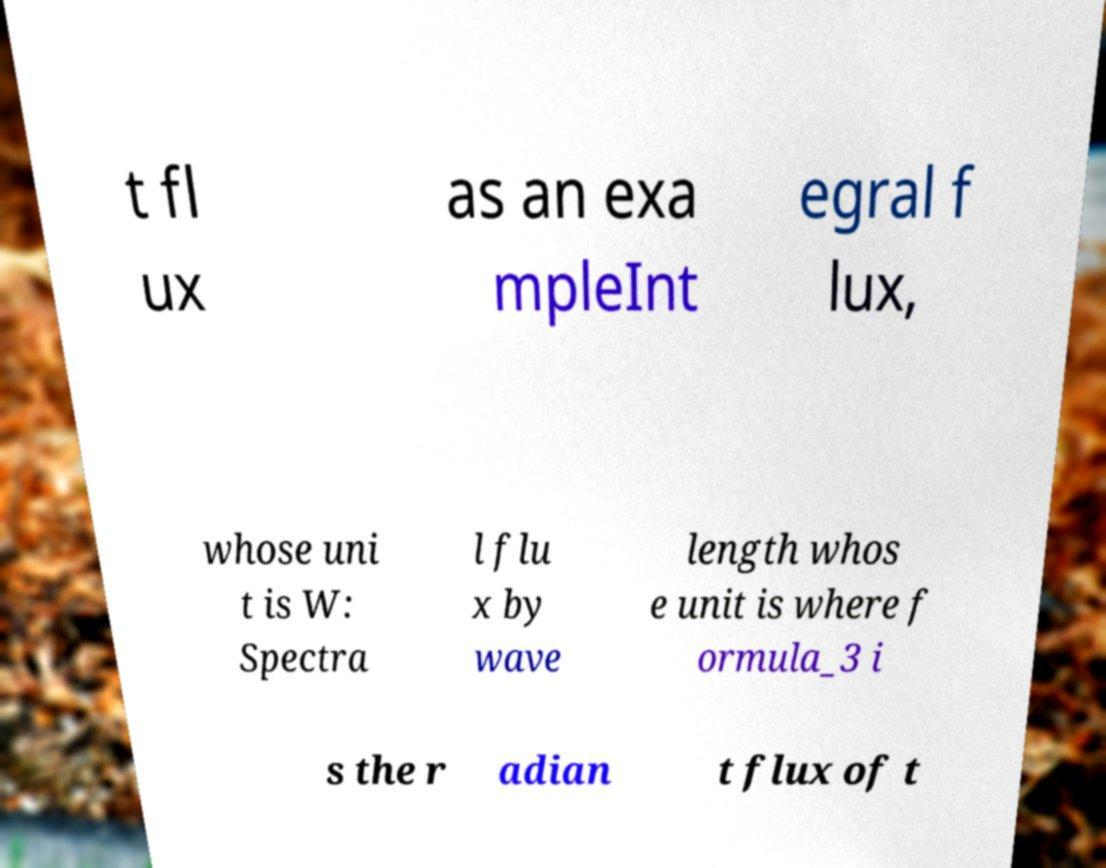For documentation purposes, I need the text within this image transcribed. Could you provide that? t fl ux as an exa mpleInt egral f lux, whose uni t is W: Spectra l flu x by wave length whos e unit is where f ormula_3 i s the r adian t flux of t 